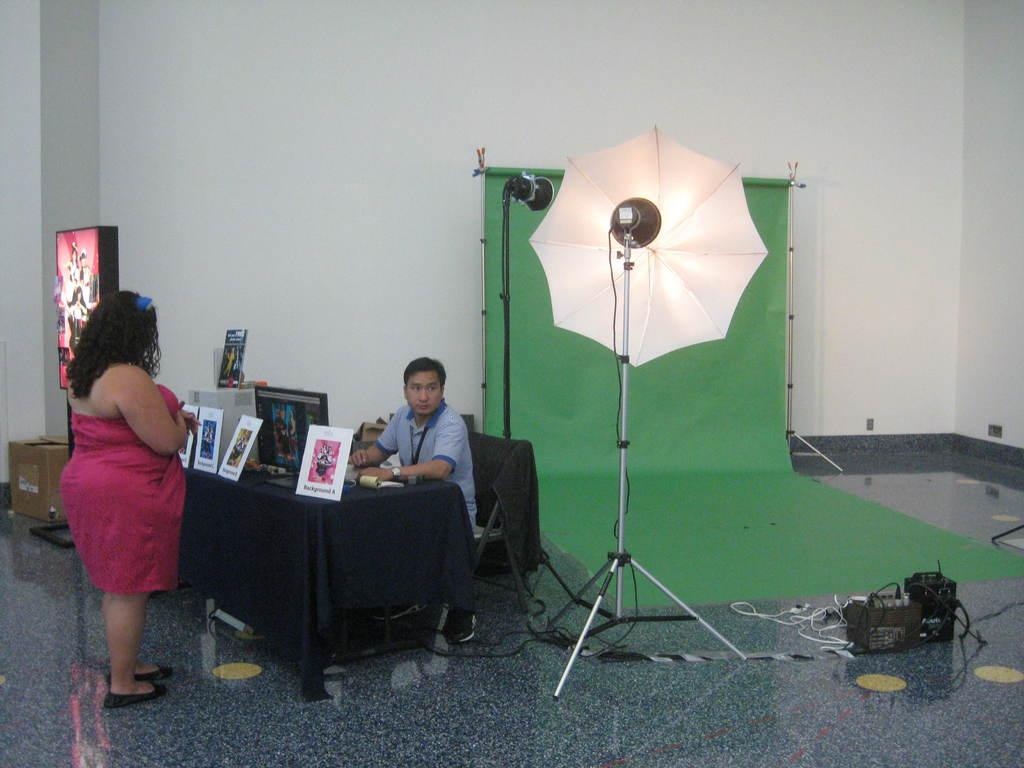What is the man in the image doing? The man is sitting on a chair in the image. Who is in front of the man in the image? There is a woman standing in front of the man in the image. What can be seen on the table in the image? There are photo frames on a table in the image. What grade is the bee learning in the image? There is no bee present in the image, and therefore no grade or learning can be observed. 